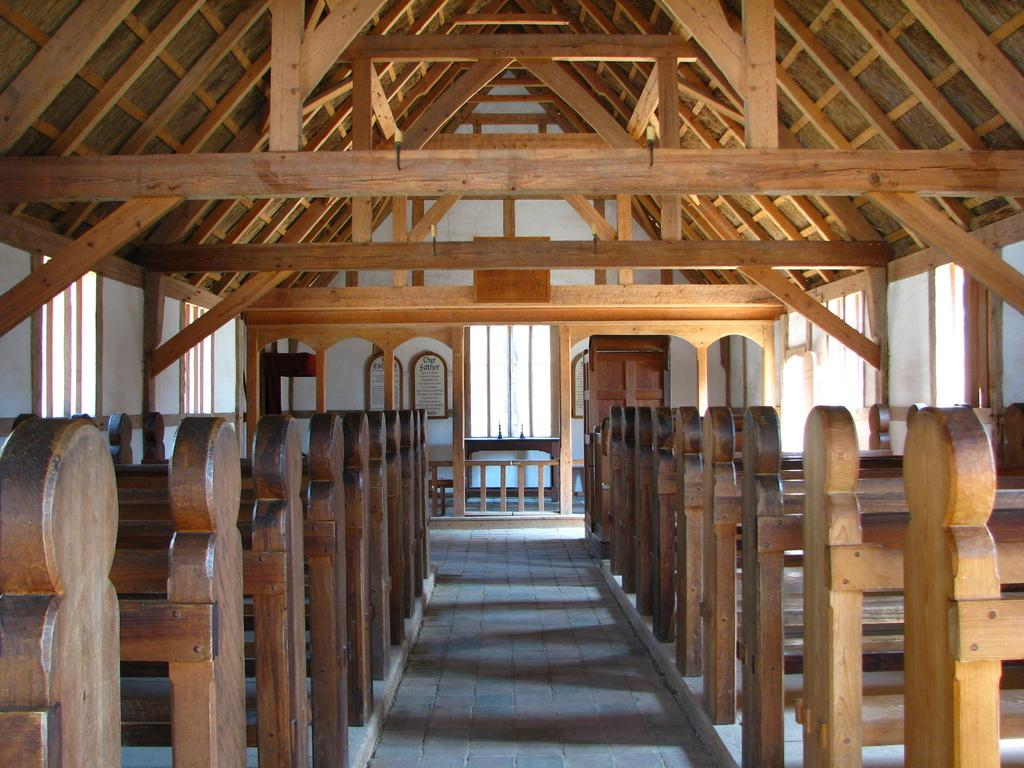What type of furniture is placed on the floor in the image? There are wooden benches on the floor in the image. How many windows can be seen in the image? There are many windows in the image. How many elbow-shaped objects can be seen in the image? There are no elbow-shaped objects present in the image. Is there a toothbrush visible in the image? There is no toothbrush present in the image. Is the image covered in snow? There is no mention of snow in the image, and it cannot be determined from the provided facts. 